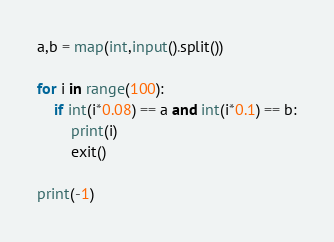<code> <loc_0><loc_0><loc_500><loc_500><_Python_>a,b = map(int,input().split())

for i in range(100):
    if int(i*0.08) == a and int(i*0.1) == b:
        print(i)
        exit()

print(-1)</code> 